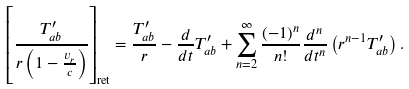Convert formula to latex. <formula><loc_0><loc_0><loc_500><loc_500>\left [ \frac { T ^ { \prime } _ { a b } } { r \left ( 1 - \frac { v _ { r } } { c } \right ) } \right ] _ { \text {ret} } = \frac { T _ { a b } ^ { \prime } } { r } - \frac { d } { d t } T _ { a b } ^ { \prime } + \sum _ { n = 2 } ^ { \infty } \frac { ( - 1 ) ^ { n } } { n ! } \frac { d ^ { n } } { d t ^ { n } } \left ( r ^ { n - 1 } T ^ { \prime } _ { a b } \right ) .</formula> 